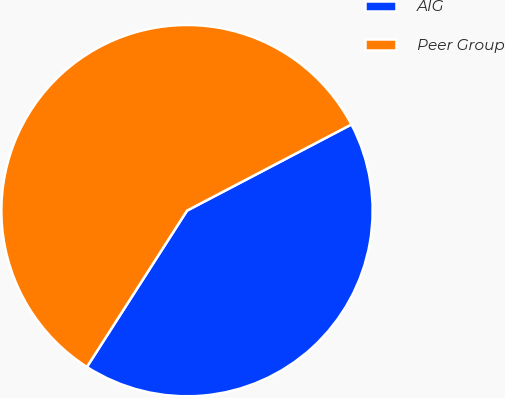<chart> <loc_0><loc_0><loc_500><loc_500><pie_chart><fcel>AIG<fcel>Peer Group<nl><fcel>41.75%<fcel>58.25%<nl></chart> 